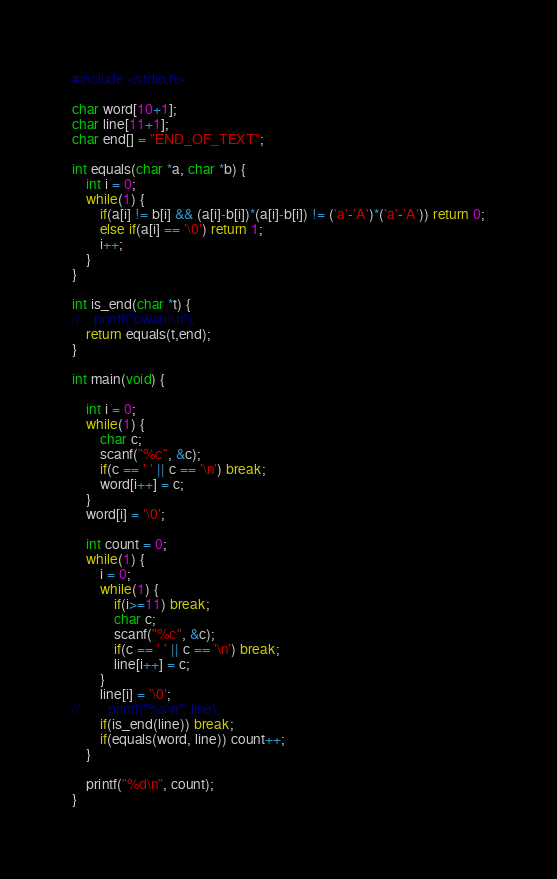<code> <loc_0><loc_0><loc_500><loc_500><_C_>#include <stdio.h>

char word[10+1];
char line[11+1];
char end[] = "END_OF_TEXT";

int equals(char *a, char *b) {
    int i = 0;
    while(1) {
        if(a[i] != b[i] && (a[i]-b[i])*(a[i]-b[i]) != ('a'-'A')*('a'-'A')) return 0;
        else if(a[i] == '\0') return 1;
        i++;
    }
}

int is_end(char *t) {
//    printf("owari!\n");
    return equals(t,end);
}

int main(void) {

    int i = 0;
    while(1) {
        char c;
        scanf("%c", &c);
        if(c == ' ' || c == '\n') break;
        word[i++] = c;
    }
    word[i] = '\0';

    int count = 0;
    while(1) {
        i = 0;
        while(1) {
            if(i>=11) break;
            char c;
            scanf("%c", &c);
            if(c == ' ' || c == '\n') break;
            line[i++] = c;
        }
        line[i] = '\0';
//        printf("%s\n", line);
        if(is_end(line)) break;
        if(equals(word, line)) count++;
    }

    printf("%d\n", count);
}</code> 